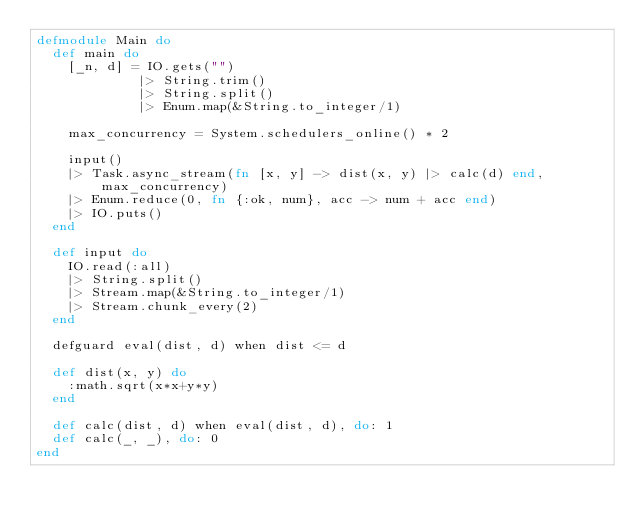Convert code to text. <code><loc_0><loc_0><loc_500><loc_500><_Elixir_>defmodule Main do
  def main do
    [_n, d] = IO.gets("")
             |> String.trim()
             |> String.split()
             |> Enum.map(&String.to_integer/1)

    max_concurrency = System.schedulers_online() * 2

    input()
    |> Task.async_stream(fn [x, y] -> dist(x, y) |> calc(d) end, max_concurrency)
    |> Enum.reduce(0, fn {:ok, num}, acc -> num + acc end)
    |> IO.puts()
  end

  def input do
    IO.read(:all)
    |> String.split()
    |> Stream.map(&String.to_integer/1)
    |> Stream.chunk_every(2)
  end

  defguard eval(dist, d) when dist <= d

  def dist(x, y) do
    :math.sqrt(x*x+y*y)
  end

  def calc(dist, d) when eval(dist, d), do: 1
  def calc(_, _), do: 0
end
</code> 